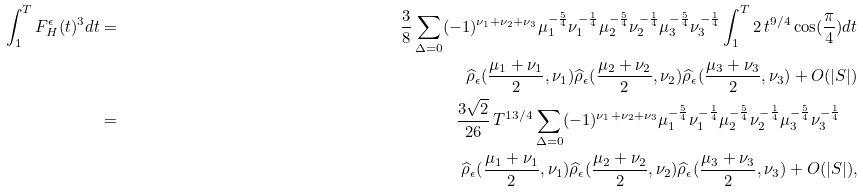Convert formula to latex. <formula><loc_0><loc_0><loc_500><loc_500>\int _ { 1 } ^ { T } F ^ { \epsilon } _ { H } ( t ) ^ { 3 } d t & = & \frac { 3 } { 8 } \sum _ { \Delta = 0 } ( - 1 ) ^ { \nu _ { 1 } + \nu _ { 2 } + \nu _ { 3 } } \mu _ { 1 } ^ { - \frac { 5 } { 4 } } \nu _ { 1 } ^ { - \frac { 1 } { 4 } } \mu _ { 2 } ^ { - \frac { 5 } { 4 } } \nu _ { 2 } ^ { - \frac { 1 } { 4 } } \mu _ { 3 } ^ { - \frac { 5 } { 4 } } \nu _ { 3 } ^ { - \frac { 1 } { 4 } } \int _ { 1 } ^ { T } 2 \, t ^ { 9 / 4 } \cos ( \frac { \pi } { 4 } ) d t \\ & & \widehat { \rho } _ { \epsilon } ( \frac { \mu _ { 1 } + \nu _ { 1 } } { 2 } , \nu _ { 1 } ) \widehat { \rho } _ { \epsilon } ( \frac { \mu _ { 2 } + \nu _ { 2 } } { 2 } , \nu _ { 2 } ) \widehat { \rho } _ { \epsilon } ( \frac { \mu _ { 3 } + \nu _ { 3 } } { 2 } , \nu _ { 3 } ) + O ( | S | ) \\ & = & \frac { 3 \sqrt { 2 } } { 2 6 } \, T ^ { 1 3 / 4 } \sum _ { \Delta = 0 } ( - 1 ) ^ { \nu _ { 1 } + \nu _ { 2 } + \nu _ { 3 } } \mu _ { 1 } ^ { - \frac { 5 } { 4 } } \nu _ { 1 } ^ { - \frac { 1 } { 4 } } \mu _ { 2 } ^ { - \frac { 5 } { 4 } } \nu _ { 2 } ^ { - \frac { 1 } { 4 } } \mu _ { 3 } ^ { - \frac { 5 } { 4 } } \nu _ { 3 } ^ { - \frac { 1 } { 4 } } \quad \\ & & \widehat { \rho } _ { \epsilon } ( \frac { \mu _ { 1 } + \nu _ { 1 } } { 2 } , \nu _ { 1 } ) \widehat { \rho } _ { \epsilon } ( \frac { \mu _ { 2 } + \nu _ { 2 } } { 2 } , \nu _ { 2 } ) \widehat { \rho } _ { \epsilon } ( \frac { \mu _ { 3 } + \nu _ { 3 } } { 2 } , \nu _ { 3 } ) + O ( | S | ) ,</formula> 